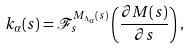<formula> <loc_0><loc_0><loc_500><loc_500>k _ { \alpha } ( s ) = \mathcal { F } _ { s } ^ { M _ { \Lambda _ { \alpha } } ( s ) } \left ( \frac { \partial M ( s ) } { \partial s } \right ) ,</formula> 